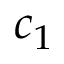Convert formula to latex. <formula><loc_0><loc_0><loc_500><loc_500>c _ { 1 }</formula> 